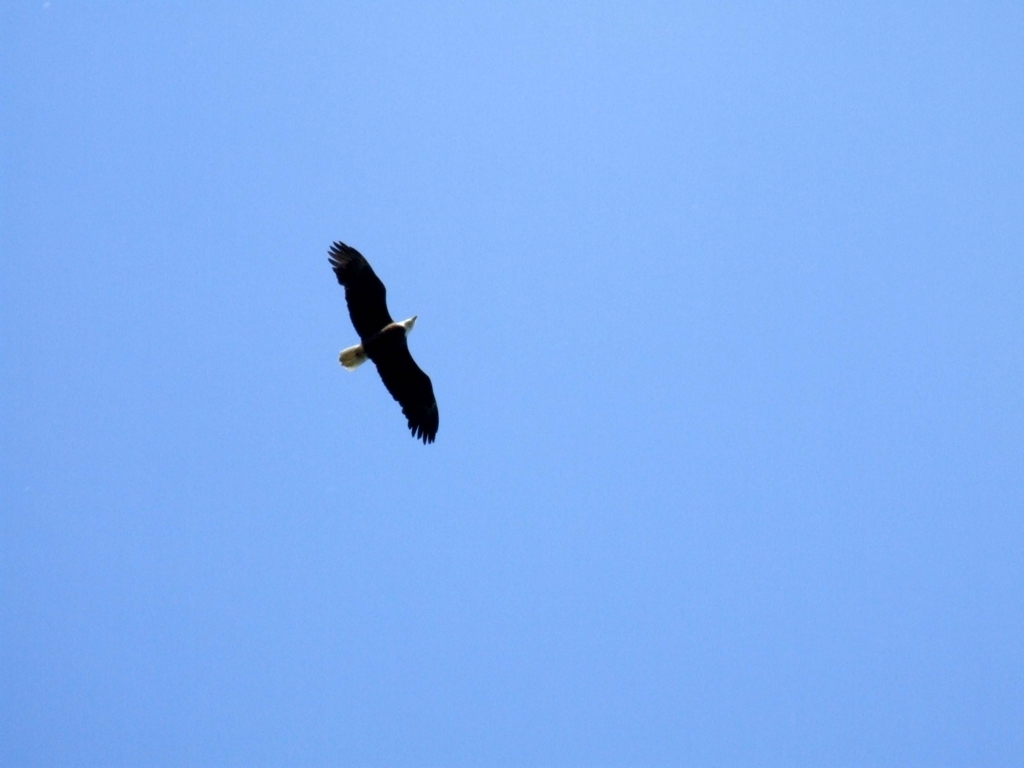Could you tell me about the habitat of the bald eagle? Bald eagles are typically found near large bodies of open water with an abundant food supply and old-growth trees for nesting. They prefer habitats such as lakes, rivers, marshes, and coastlines, where they can fish and hunt for food. What is the significance of the bald eagle? The bald eagle holds great significance as a national symbol of the United States, representing freedom and strength. It is also an important cultural symbol for various indigenous peoples, valued for its spiritual significance and revered in many stories and traditions. 